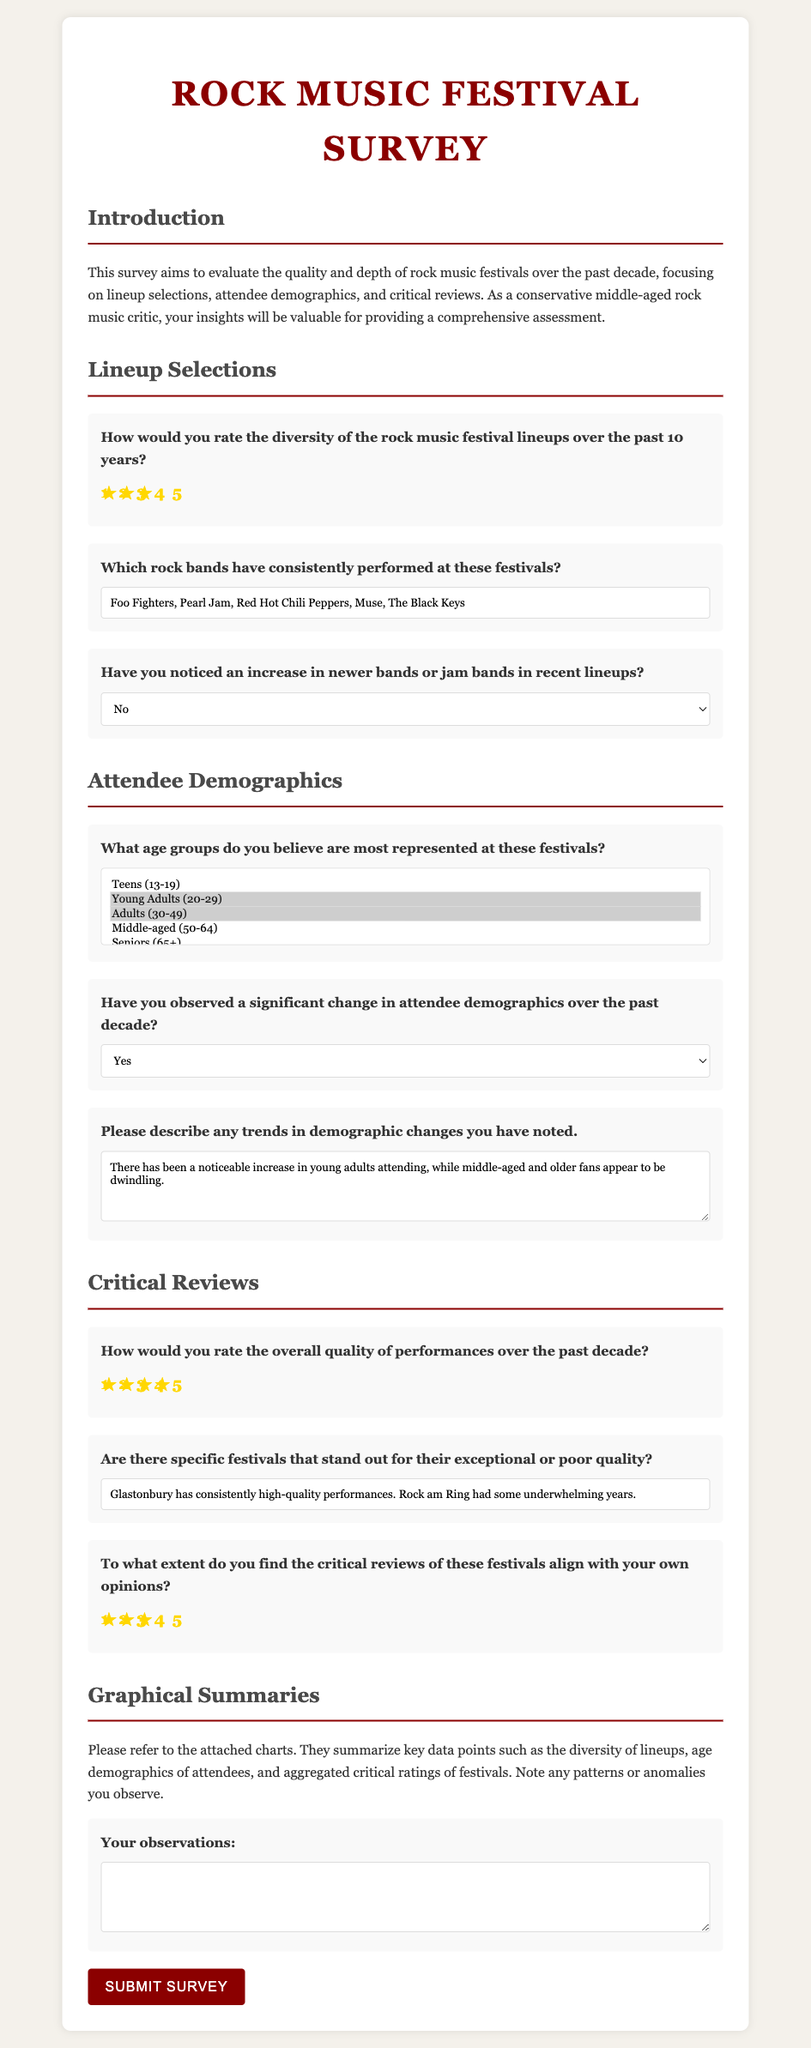How would you rate the diversity of the rock music festival lineups over the past 10 years? The document provides a rating for the diversity of lineups on a scale of 1 to 5, with the selected option being 3.
Answer: 3 Which rock bands have consistently performed at these festivals? The document lists bands that have consistently performed at festivals as reported by the survey respondent, which includes "Foo Fighters, Pearl Jam, Red Hot Chili Peppers, Muse, The Black Keys."
Answer: Foo Fighters, Pearl Jam, Red Hot Chili Peppers, Muse, The Black Keys Have you noticed an increase in newer bands or jam bands in recent lineups? The document indicates the selected response to this question is "No."
Answer: No What age groups do you believe are most represented at these festivals? The age groups selected in the document include Young Adults (20-29) and Adults (30-49), among others.
Answer: Young Adults (20-29), Adults (30-49) Have you observed a significant change in attendee demographics over the past decade? According to the document, the selected response to this question is "Yes."
Answer: Yes What notable festivals stand out for their exceptional or poor quality? The document reports Glastonbury for its high-quality performances and Rock am Ring for having some underwhelming years.
Answer: Glastonbury has consistently high-quality performances. Rock am Ring had some underwhelming years To what extent do you find the critical reviews of these festivals align with your own opinions? The document shows the respondent rated this alignment as 3.
Answer: 3 What trends in demographic changes have you noted? The document mentions an increase in young adults attending while older fans appear to be dwindling.
Answer: Increase in young adults, dwindling older fans 